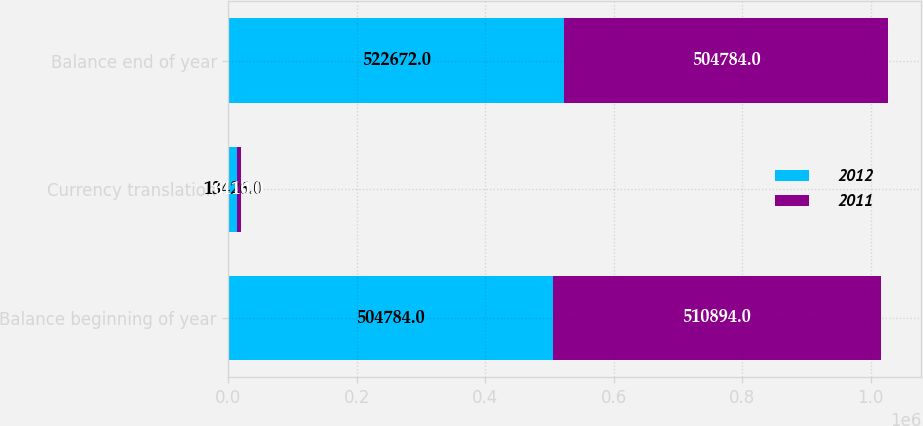Convert chart to OTSL. <chart><loc_0><loc_0><loc_500><loc_500><stacked_bar_chart><ecel><fcel>Balance beginning of year<fcel>Currency translation<fcel>Balance end of year<nl><fcel>2012<fcel>504784<fcel>13426<fcel>522672<nl><fcel>2011<fcel>510894<fcel>6110<fcel>504784<nl></chart> 